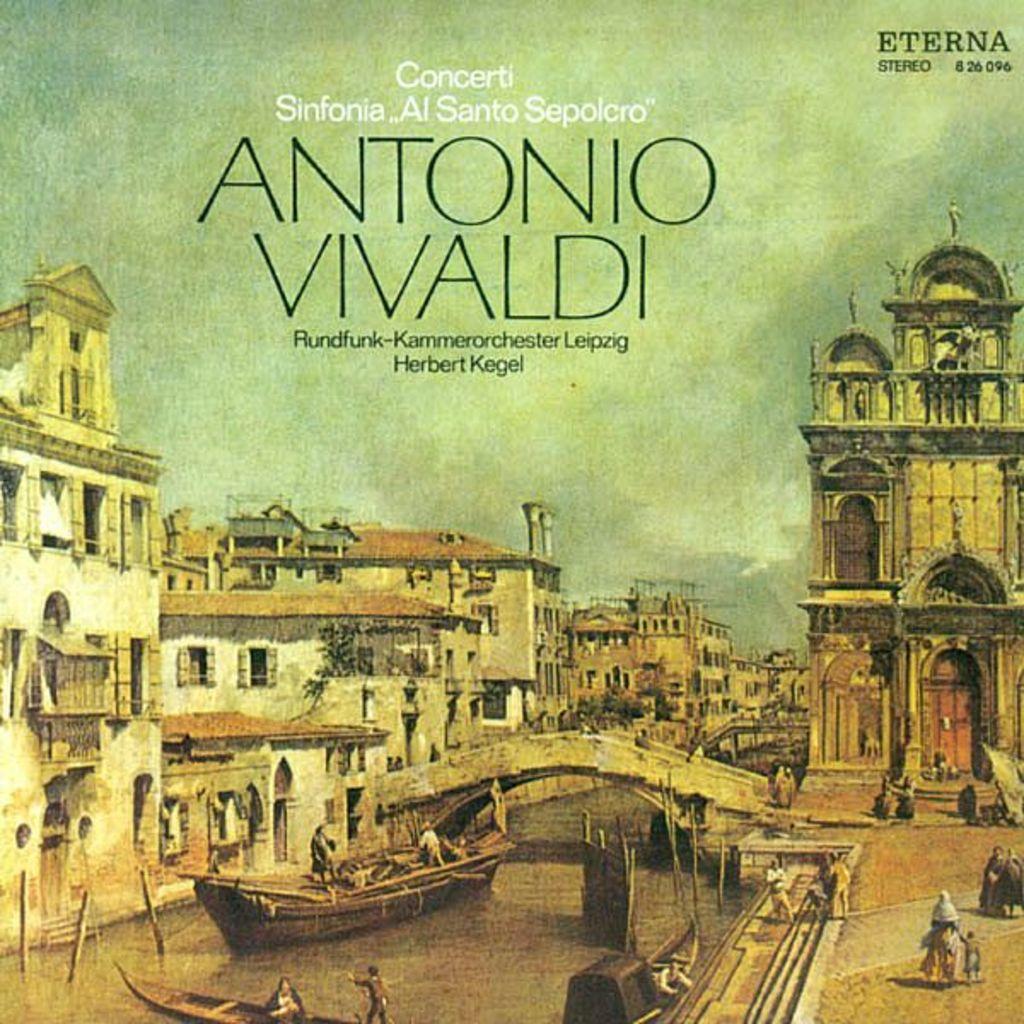What is the title of the book?
Provide a short and direct response. Antonio vivaldi. What is the first letter of the first name of the title?
Keep it short and to the point. A. 